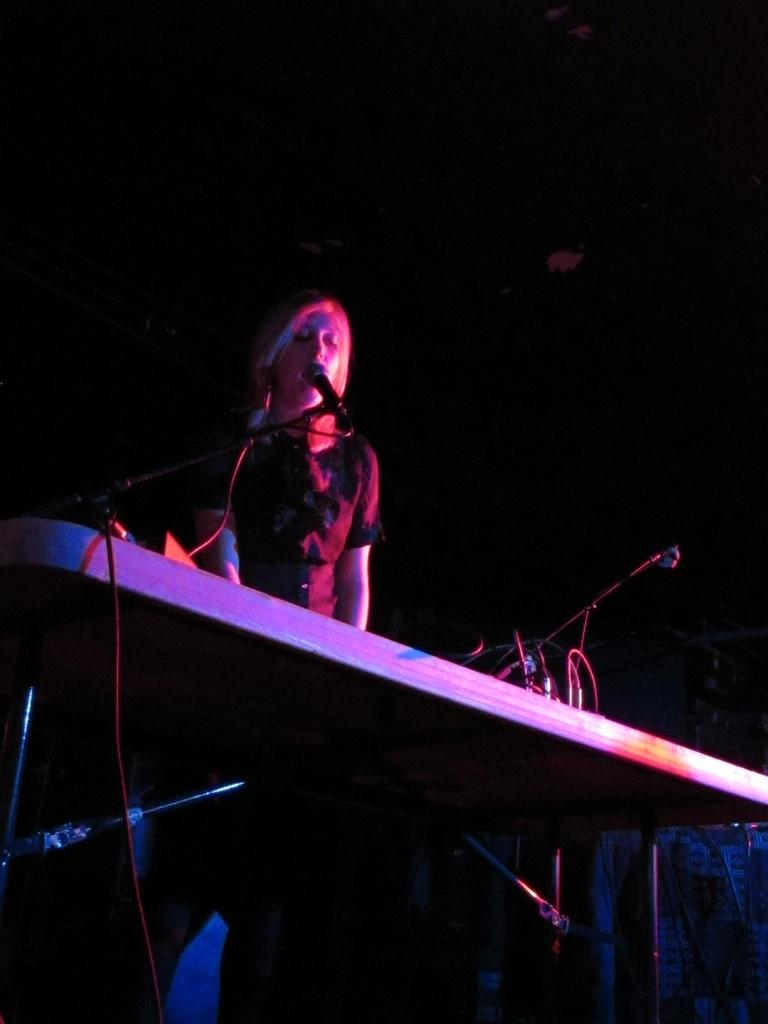What is the woman doing in the image? The woman is standing at a table in the image. What can be seen on the table? There are cables and a mic on a stand on the table. Are there any other objects on the table? Yes, there are other objects on the table. Who is the creator of the humor in the image? There is no humor present in the image, so it is not possible to determine who the creator might be. 